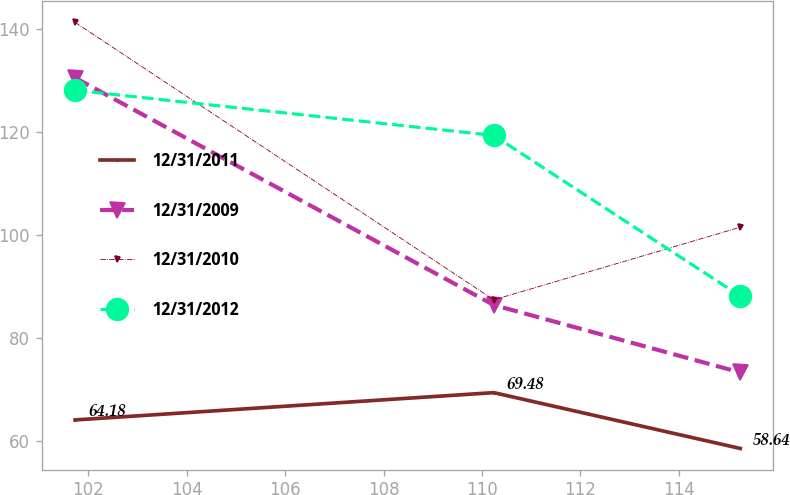Convert chart. <chart><loc_0><loc_0><loc_500><loc_500><line_chart><ecel><fcel>12/31/2011<fcel>12/31/2009<fcel>12/31/2010<fcel>12/31/2012<nl><fcel>101.73<fcel>64.18<fcel>130.6<fcel>141.37<fcel>128.18<nl><fcel>110.24<fcel>69.48<fcel>86.49<fcel>87.5<fcel>119.42<nl><fcel>115.25<fcel>58.64<fcel>73.4<fcel>101.6<fcel>88.23<nl></chart> 